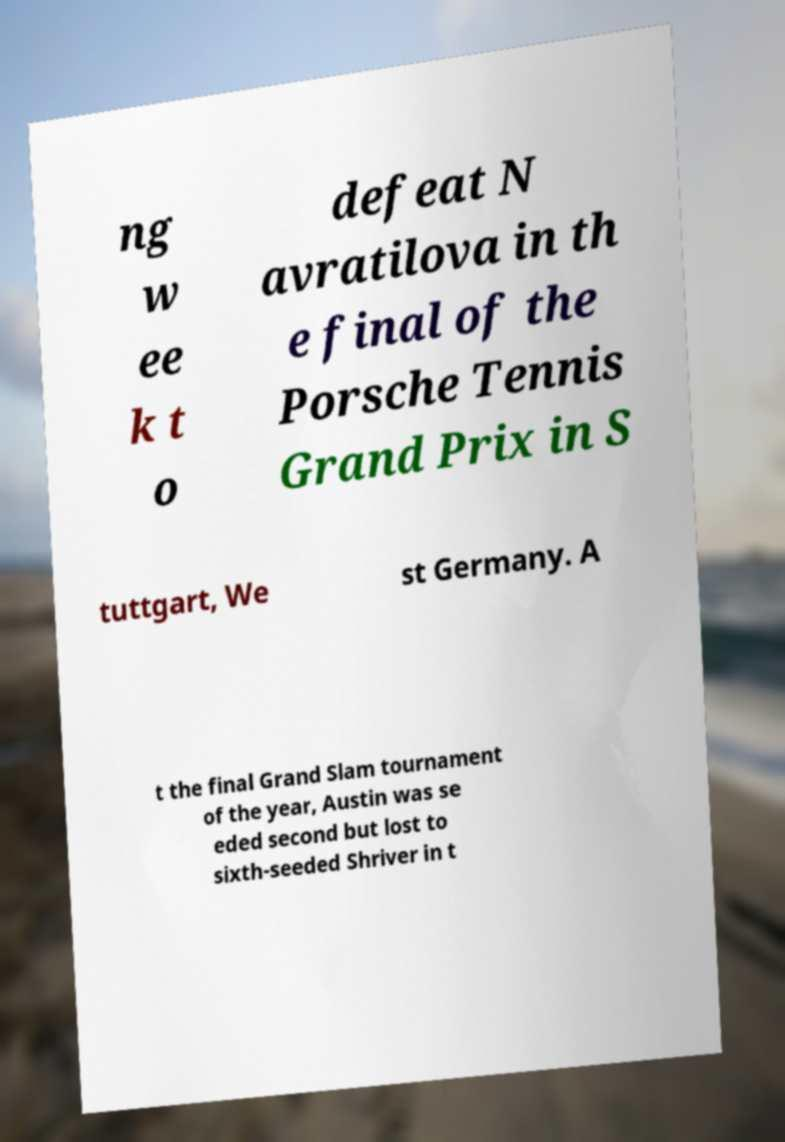Please read and relay the text visible in this image. What does it say? ng w ee k t o defeat N avratilova in th e final of the Porsche Tennis Grand Prix in S tuttgart, We st Germany. A t the final Grand Slam tournament of the year, Austin was se eded second but lost to sixth-seeded Shriver in t 